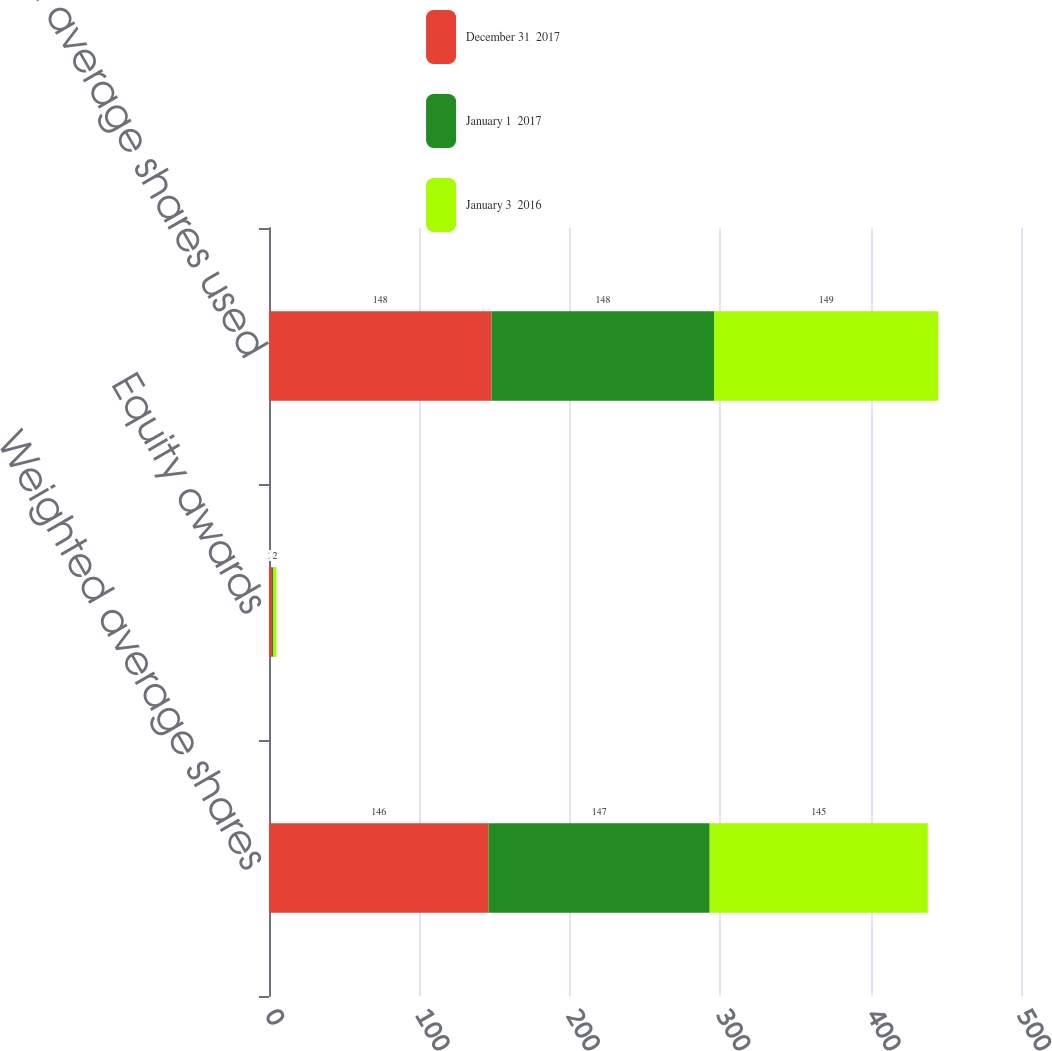Convert chart to OTSL. <chart><loc_0><loc_0><loc_500><loc_500><stacked_bar_chart><ecel><fcel>Weighted average shares<fcel>Equity awards<fcel>Weighted average shares used<nl><fcel>December 31  2017<fcel>146<fcel>2<fcel>148<nl><fcel>January 1  2017<fcel>147<fcel>1<fcel>148<nl><fcel>January 3  2016<fcel>145<fcel>2<fcel>149<nl></chart> 